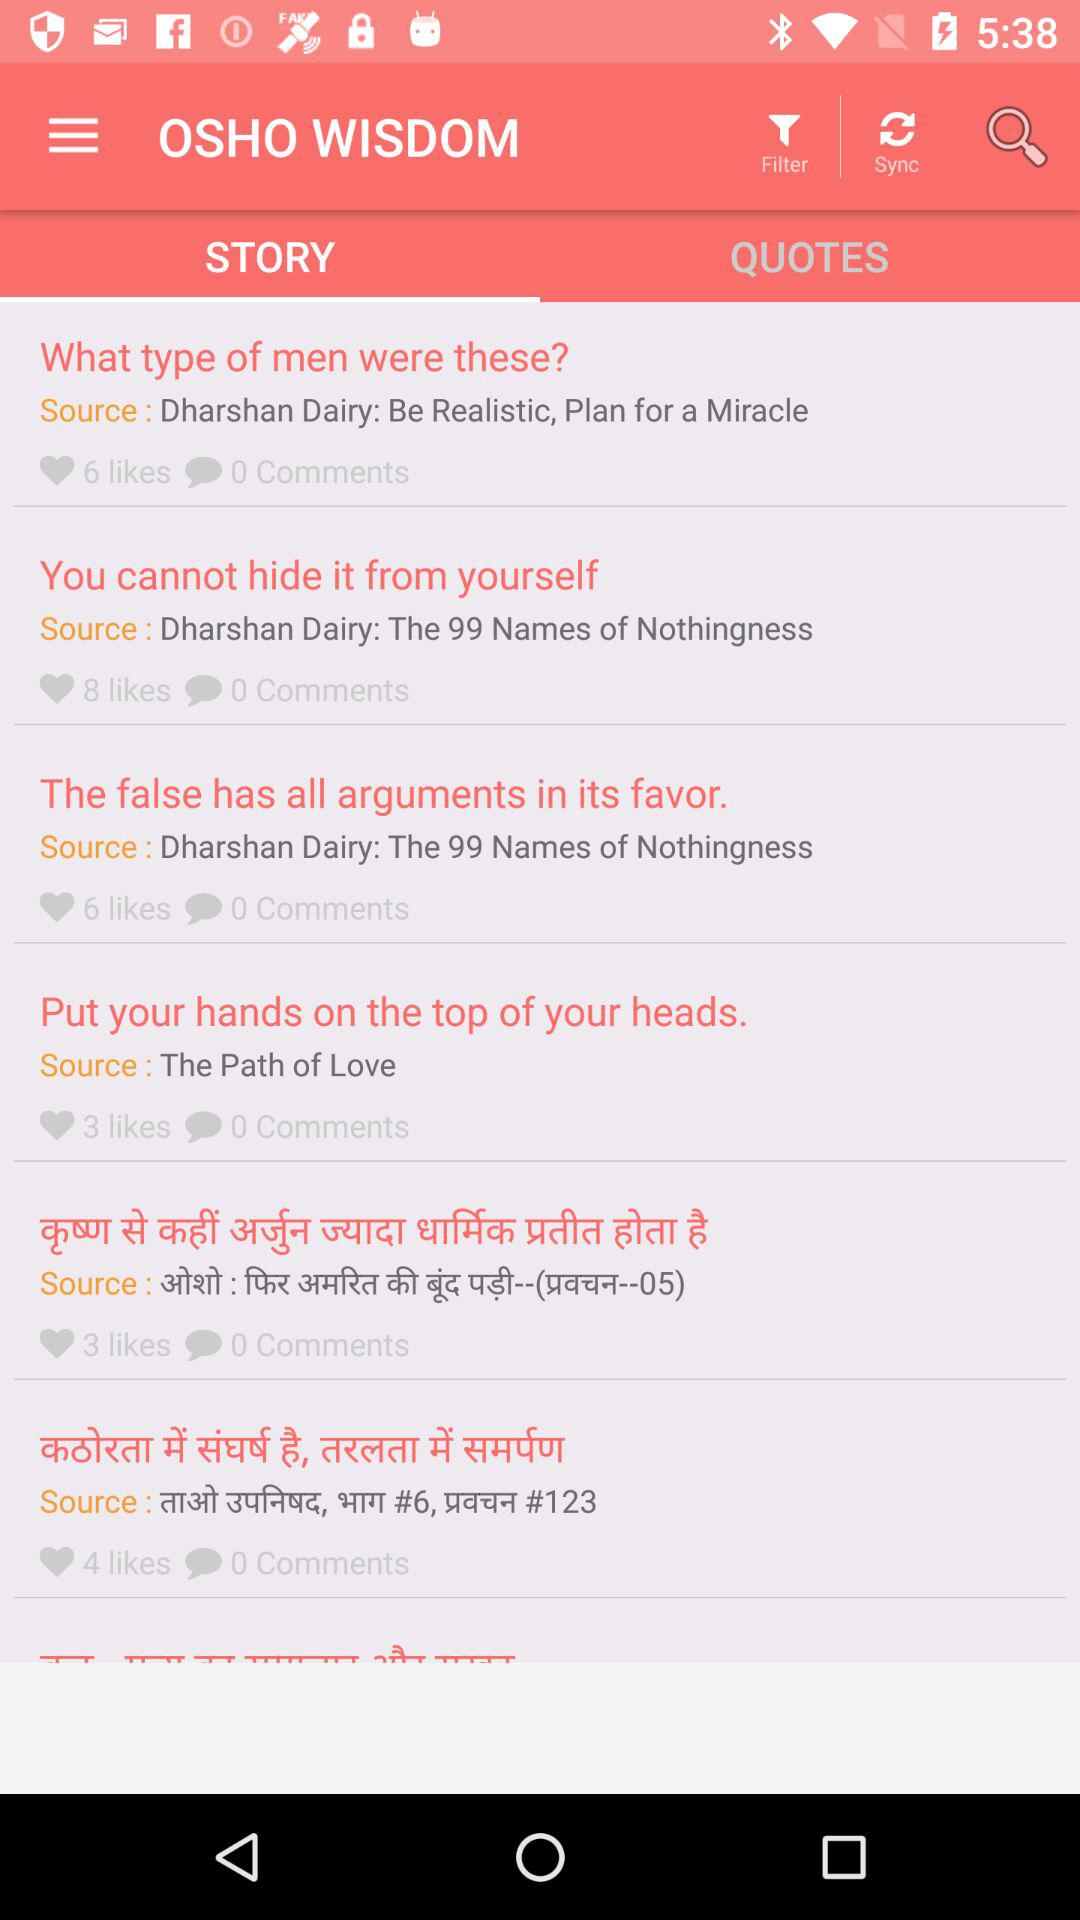How many likes does the item with the source 'The Path of Love' have?
Answer the question using a single word or phrase. 3 